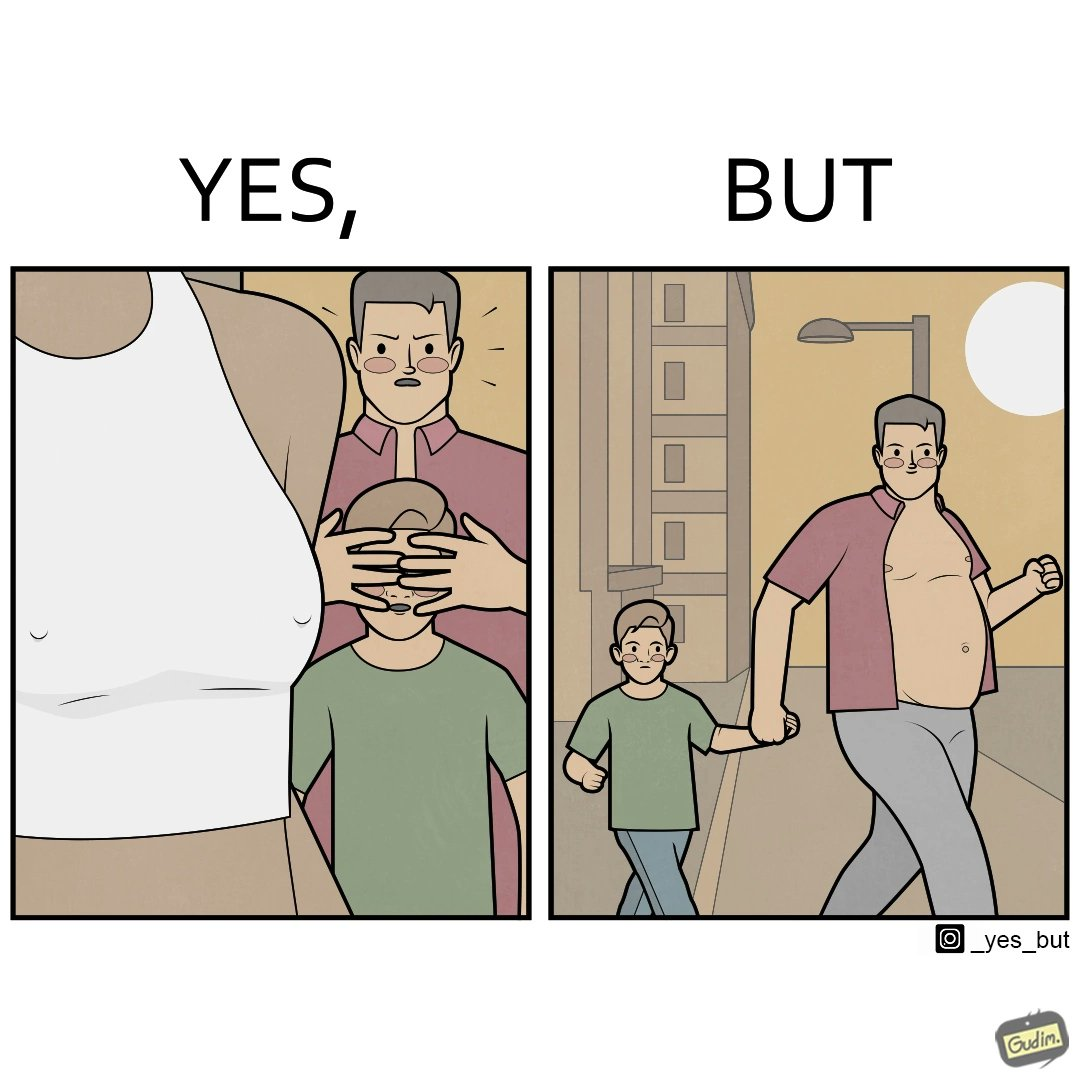What does this image depict? Although the children is hiding his children's eyes from a women but he himself is roaming in shirt open which is showing his body. 